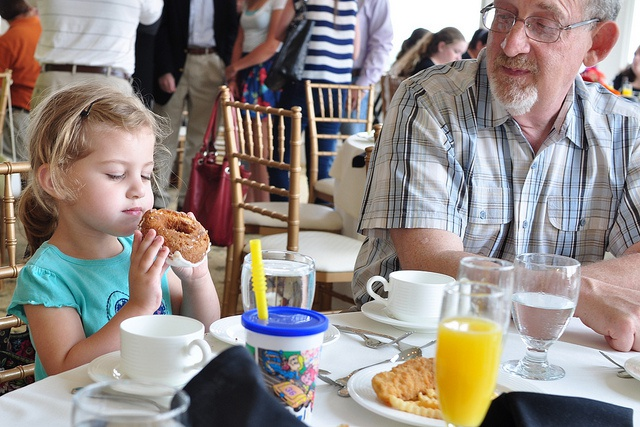Describe the objects in this image and their specific colors. I can see people in black, darkgray, lavender, and gray tones, dining table in black, lightgray, darkgray, and orange tones, people in black, gray, lightgray, pink, and darkgray tones, chair in black, lightgray, and maroon tones, and people in black, lightgray, and darkgray tones in this image. 